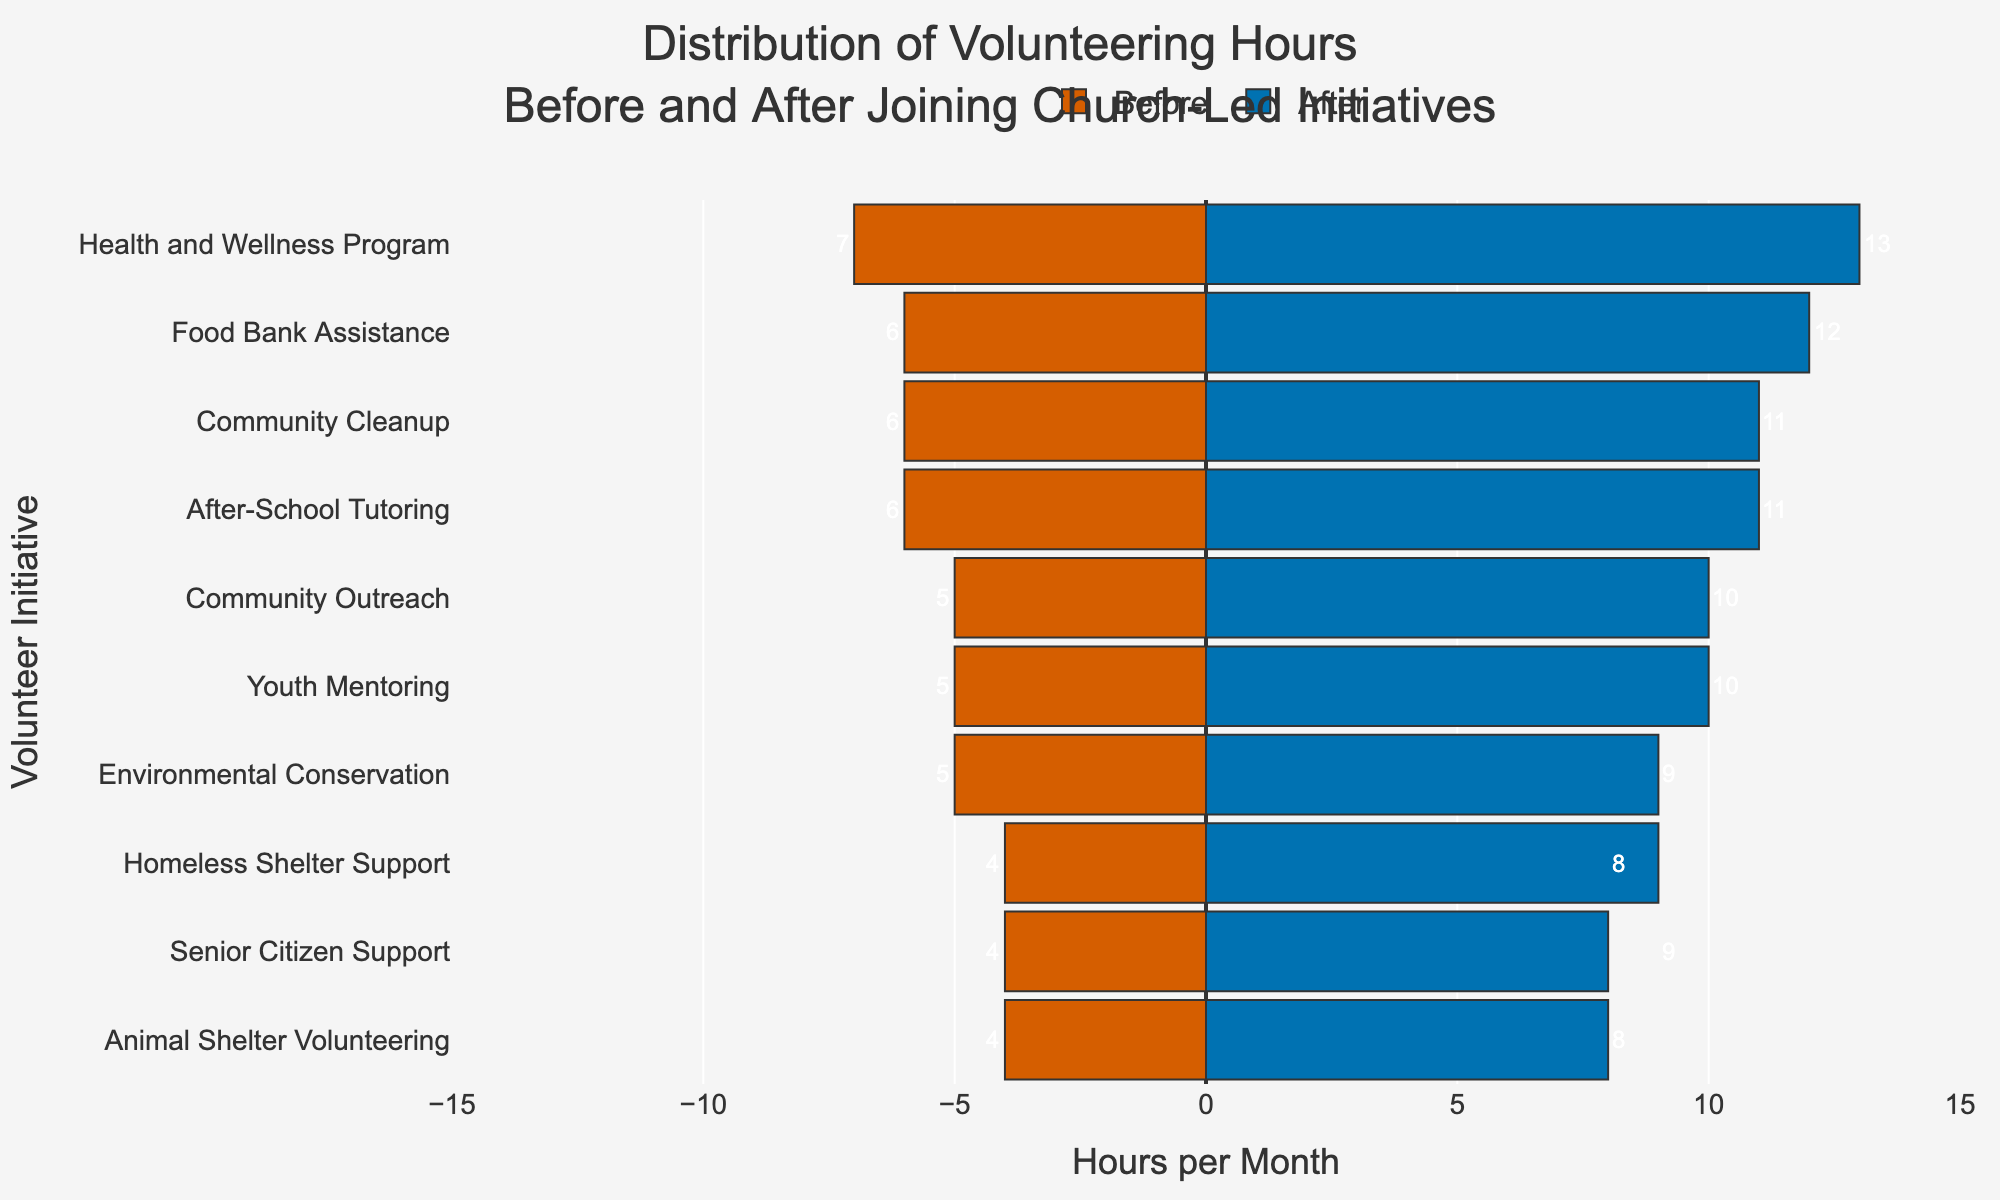How many total volunteering hours were spent on "Youth Mentoring" before and after joining the church-led initiatives? To find the total, add the hours spent before and after: 5 (before) + 10 (after) = 15.
Answer: 15 Which volunteer initiative saw the largest increase in hours after joining the church-led initiatives? Calculate the difference between 'After' and 'Before' hours for all initiatives and find the maximum. The largest increase is for "Health and Wellness Program" (13 - 7 = 6 hours).
Answer: Health and Wellness Program What is the difference in total volunteering hours between "Environmental Conservation" and "Homeless Shelter Support" after joining the church-led initiatives? "Environmental Conservation" has 9 hours; "Homeless Shelter Support" has 8 hours. The difference is 9 - 8 = 1 hour.
Answer: 1 hour Which initiative had the same amount of hours increase as "Food Bank Assistance" after joining the church-led initiatives? "Food Bank Assistance" had an increase of 12 - 6 = 6 hours. "Health and Wellness Program" also had an increase of 6 hours (13 - 7 = 6).
Answer: Health and Wellness Program Which initiative had more hours dedicated to it before joining the church-led initiatives: "Community Cleanup" or "After-School Tutoring"? Compare the 'Before' hours for "Community Cleanup" (6 hours) and "After-School Tutoring" (6 hours). Both had the same hours.
Answer: Both had the same hours What is the total number of volunteering hours for "Senior Citizen Support" before and after joining the church-led initiatives? Add the hours before and after: 4 (before) + 9 (after) = 13 hours.
Answer: 13 hours Is there any volunteer initiative where the number of hours stayed the same before and after joining the church-led initiatives? Compare 'Before' and 'After' hours for all initiatives. None of the initiatives have the same 'Before' and 'After' hours.
Answer: No Which initiative saw the smallest increase in volunteering hours after joining the church-led initiatives? Calculate the difference between 'After' and 'Before' hours for all initiatives. The smallest increase is for "Animal Shelter Volunteering" (8 - 4 = 4 hours).
Answer: Animal Shelter Volunteering On average, how many more hours were volunteered per initiative after joining the church-led initiatives compared to before? Calculate the differences for all initiatives, sum them, and divide by the number of initiatives: (5-10 + 4-8 + 6-12 + 5-10 + 4-9 + 6-11 + 7-13 + 5-9 + 4-8 + 6-11) / 10 = 5.
Answer: 5 hours 